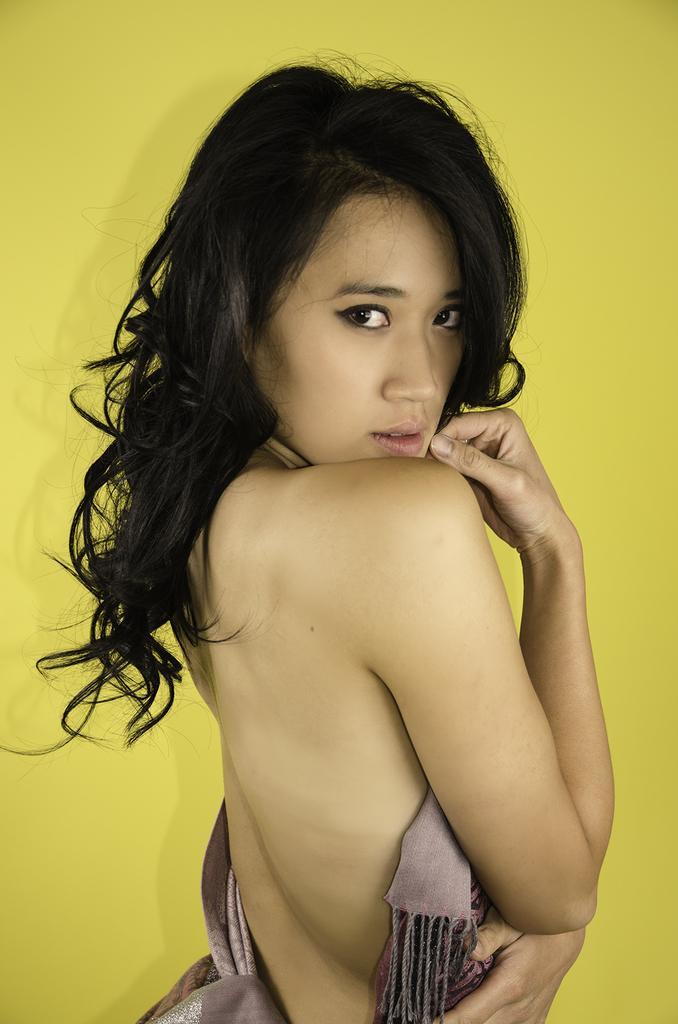Can you describe this image briefly? In the front of the image I can see a woman. There is a yellow background. 